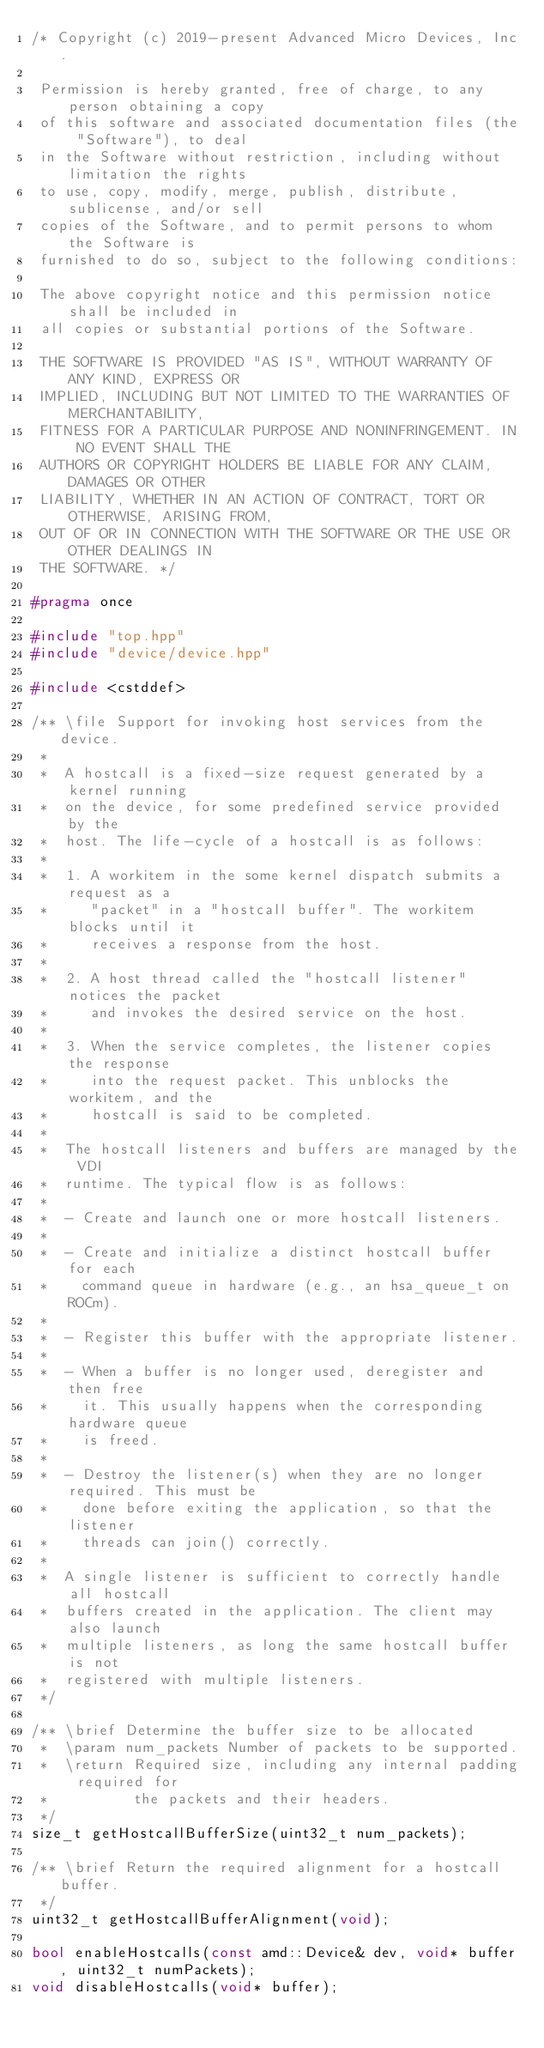Convert code to text. <code><loc_0><loc_0><loc_500><loc_500><_C++_>/* Copyright (c) 2019-present Advanced Micro Devices, Inc.

 Permission is hereby granted, free of charge, to any person obtaining a copy
 of this software and associated documentation files (the "Software"), to deal
 in the Software without restriction, including without limitation the rights
 to use, copy, modify, merge, publish, distribute, sublicense, and/or sell
 copies of the Software, and to permit persons to whom the Software is
 furnished to do so, subject to the following conditions:

 The above copyright notice and this permission notice shall be included in
 all copies or substantial portions of the Software.

 THE SOFTWARE IS PROVIDED "AS IS", WITHOUT WARRANTY OF ANY KIND, EXPRESS OR
 IMPLIED, INCLUDING BUT NOT LIMITED TO THE WARRANTIES OF MERCHANTABILITY,
 FITNESS FOR A PARTICULAR PURPOSE AND NONINFRINGEMENT. IN NO EVENT SHALL THE
 AUTHORS OR COPYRIGHT HOLDERS BE LIABLE FOR ANY CLAIM, DAMAGES OR OTHER
 LIABILITY, WHETHER IN AN ACTION OF CONTRACT, TORT OR OTHERWISE, ARISING FROM,
 OUT OF OR IN CONNECTION WITH THE SOFTWARE OR THE USE OR OTHER DEALINGS IN
 THE SOFTWARE. */

#pragma once

#include "top.hpp"
#include "device/device.hpp"

#include <cstddef>

/** \file Support for invoking host services from the device.
 *
 *  A hostcall is a fixed-size request generated by a kernel running
 *  on the device, for some predefined service provided by the
 *  host. The life-cycle of a hostcall is as follows:
 *
 *  1. A workitem in the some kernel dispatch submits a request as a
 *     "packet" in a "hostcall buffer". The workitem blocks until it
 *     receives a response from the host.
 *
 *  2. A host thread called the "hostcall listener" notices the packet
 *     and invokes the desired service on the host.
 *
 *  3. When the service completes, the listener copies the response
 *     into the request packet. This unblocks the workitem, and the
 *     hostcall is said to be completed.
 *
 *  The hostcall listeners and buffers are managed by the VDI
 *  runtime. The typical flow is as follows:
 *
 *  - Create and launch one or more hostcall listeners.
 *
 *  - Create and initialize a distinct hostcall buffer for each
 *    command queue in hardware (e.g., an hsa_queue_t on ROCm).
 *
 *  - Register this buffer with the appropriate listener.
 *
 *  - When a buffer is no longer used, deregister and then free
 *    it. This usually happens when the corresponding hardware queue
 *    is freed.
 *
 *  - Destroy the listener(s) when they are no longer required. This must be
 *    done before exiting the application, so that the listener
 *    threads can join() correctly.
 *
 *  A single listener is sufficient to correctly handle all hostcall
 *  buffers created in the application. The client may also launch
 *  multiple listeners, as long the same hostcall buffer is not
 *  registered with multiple listeners.
 */

/** \brief Determine the buffer size to be allocated
 *  \param num_packets Number of packets to be supported.
 *  \return Required size, including any internal padding required for
 *          the packets and their headers.
 */
size_t getHostcallBufferSize(uint32_t num_packets);

/** \brief Return the required alignment for a hostcall buffer.
 */
uint32_t getHostcallBufferAlignment(void);

bool enableHostcalls(const amd::Device& dev, void* buffer, uint32_t numPackets);
void disableHostcalls(void* buffer);
</code> 